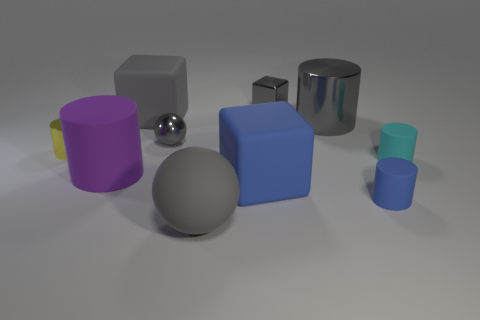Subtract all tiny rubber cylinders. How many cylinders are left? 3 Subtract all brown cylinders. How many gray blocks are left? 2 Subtract all blue cubes. How many cubes are left? 2 Subtract all spheres. How many objects are left? 8 Subtract 1 spheres. How many spheres are left? 1 Subtract 0 green cylinders. How many objects are left? 10 Subtract all blue cylinders. Subtract all yellow spheres. How many cylinders are left? 4 Subtract all small objects. Subtract all green cylinders. How many objects are left? 5 Add 8 big purple rubber things. How many big purple rubber things are left? 9 Add 7 gray cylinders. How many gray cylinders exist? 8 